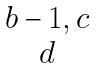Convert formula to latex. <formula><loc_0><loc_0><loc_500><loc_500>\begin{matrix} { b - 1 , c } \\ { d } \end{matrix}</formula> 